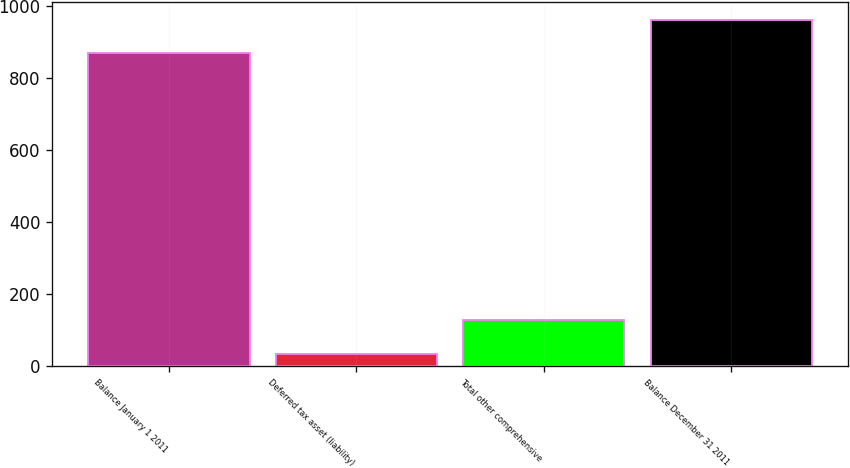Convert chart to OTSL. <chart><loc_0><loc_0><loc_500><loc_500><bar_chart><fcel>Balance January 1 2011<fcel>Deferred tax asset (liability)<fcel>Total other comprehensive<fcel>Balance December 31 2011<nl><fcel>869<fcel>35<fcel>127.2<fcel>961.2<nl></chart> 